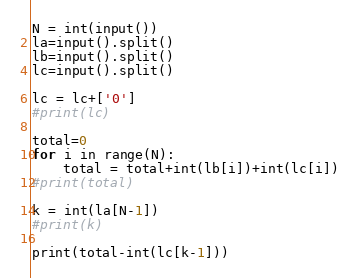Convert code to text. <code><loc_0><loc_0><loc_500><loc_500><_Python_>N = int(input())
la=input().split()
lb=input().split()
lc=input().split()

lc = lc+['0']
#print(lc)

total=0
for i in range(N):
    total = total+int(lb[i])+int(lc[i])
#print(total)

k = int(la[N-1])
#print(k)

print(total-int(lc[k-1]))
</code> 